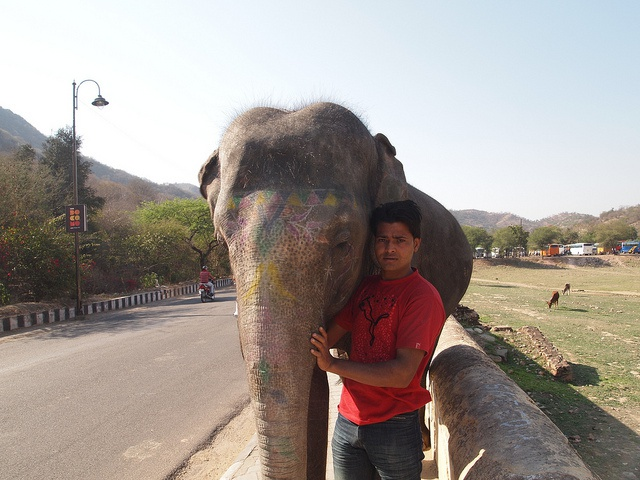Describe the objects in this image and their specific colors. I can see elephant in white, gray, black, and maroon tones, people in white, maroon, black, brown, and gray tones, bus in white, darkgray, and gray tones, bus in white, gray, darkgray, and blue tones, and motorcycle in white, black, gray, maroon, and darkgray tones in this image. 